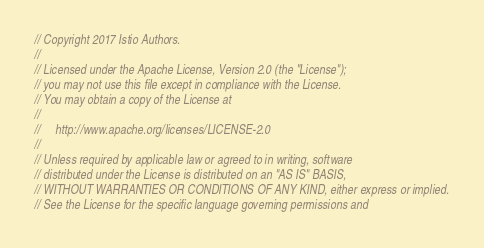<code> <loc_0><loc_0><loc_500><loc_500><_Go_>// Copyright 2017 Istio Authors.
//
// Licensed under the Apache License, Version 2.0 (the "License");
// you may not use this file except in compliance with the License.
// You may obtain a copy of the License at
//
//     http://www.apache.org/licenses/LICENSE-2.0
//
// Unless required by applicable law or agreed to in writing, software
// distributed under the License is distributed on an "AS IS" BASIS,
// WITHOUT WARRANTIES OR CONDITIONS OF ANY KIND, either express or implied.
// See the License for the specific language governing permissions and</code> 